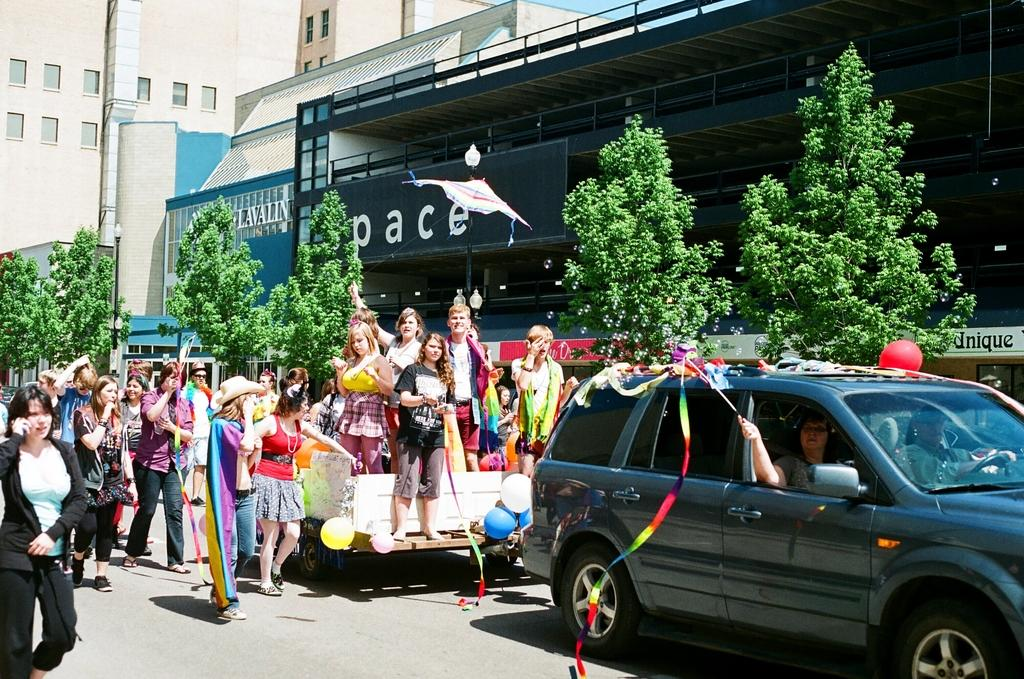What type of structures can be seen in the image? There are buildings in the image. What is located in front of the buildings? There are plants in front of the buildings. What mode of transportation is present in the image? There is a vehicle in the image. What are the girls doing on the vehicle? Few girls are standing on the vehicle. How is the vehicle moving in the image? The vehicle is traveling along with a car. What type of vegetable is being cooked by the girls on the vehicle? There is no vegetable or cooking activity present in the image. What type of silk is draped over the plants in front of the buildings? There is no silk present in the image; only plants are visible in front of the buildings. 